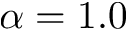Convert formula to latex. <formula><loc_0><loc_0><loc_500><loc_500>\alpha = 1 . 0</formula> 